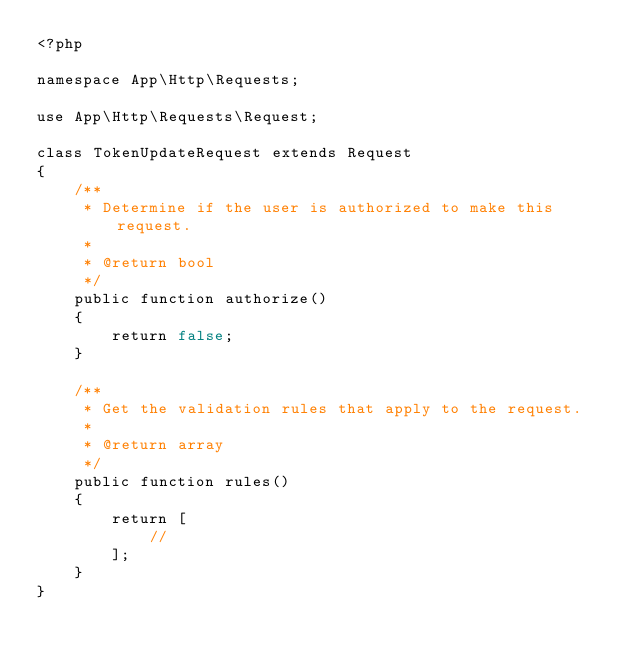<code> <loc_0><loc_0><loc_500><loc_500><_PHP_><?php

namespace App\Http\Requests;

use App\Http\Requests\Request;

class TokenUpdateRequest extends Request
{
    /**
     * Determine if the user is authorized to make this request.
     *
     * @return bool
     */
    public function authorize()
    {
        return false;
    }

    /**
     * Get the validation rules that apply to the request.
     *
     * @return array
     */
    public function rules()
    {
        return [
            //
        ];
    }
}
</code> 